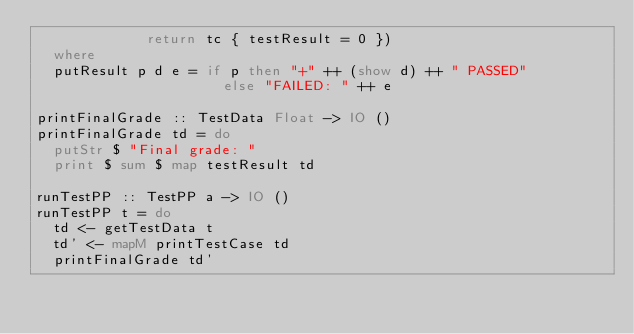<code> <loc_0><loc_0><loc_500><loc_500><_Haskell_>             return tc { testResult = 0 })
  where
  putResult p d e = if p then "+" ++ (show d) ++ " PASSED"
                      else "FAILED: " ++ e

printFinalGrade :: TestData Float -> IO ()
printFinalGrade td = do
  putStr $ "Final grade: "
  print $ sum $ map testResult td

runTestPP :: TestPP a -> IO ()
runTestPP t = do
  td <- getTestData t
  td' <- mapM printTestCase td
  printFinalGrade td'
</code> 